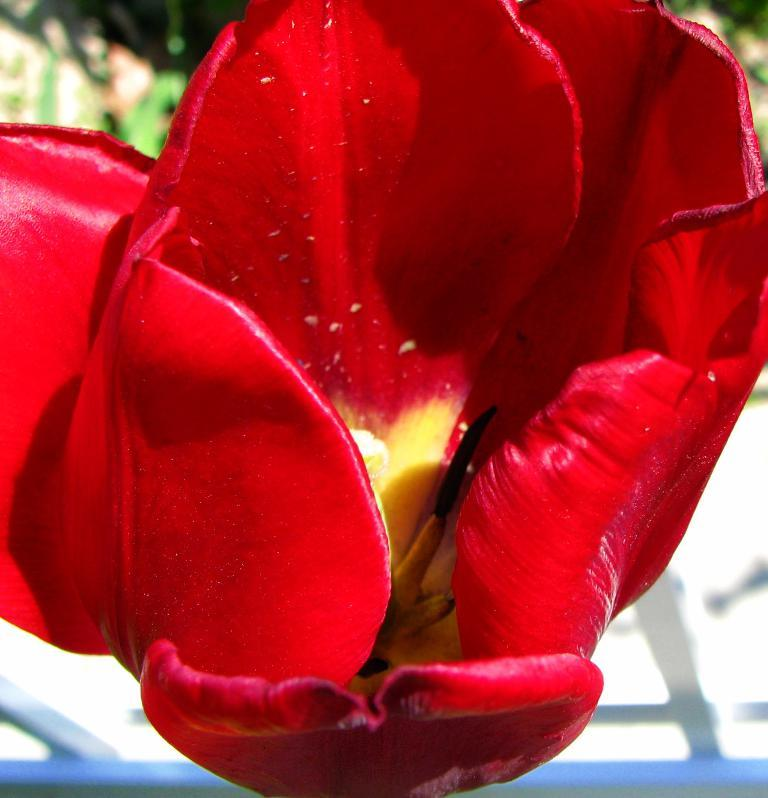What is the main subject of the image? The main subject of the image is a red color flower. Can you describe the location of the flower in the image? The flower is in the center of the image. How many rabbits can be seen playing with the plants in the image? There are no rabbits or plants present in the image; it features a red color flower in the center. What type of drawer is visible in the image? There is no drawer present in the image. 